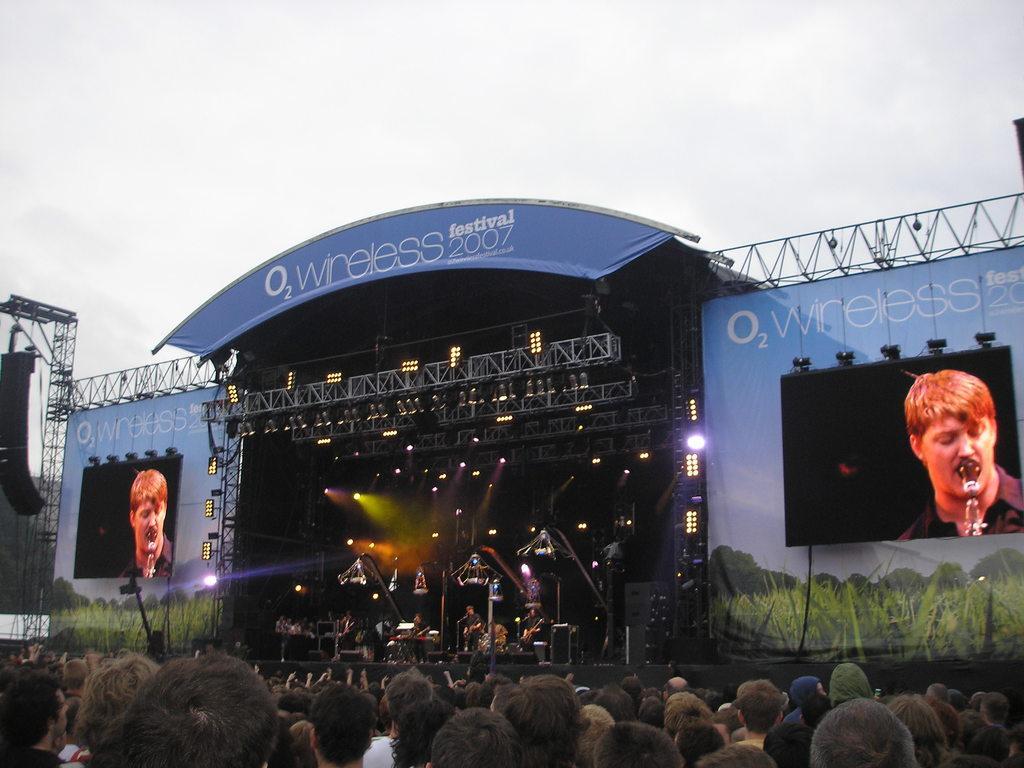How would you summarize this image in a sentence or two? In this image there are people standing, in the background there is a stage, on that stage people are performing and there are screens, lights and banners, speakers and the sky. 